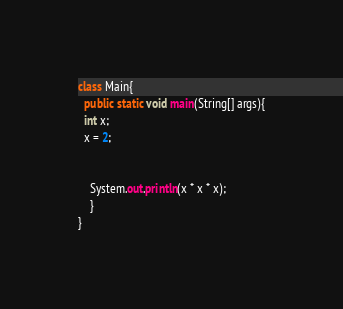Convert code to text. <code><loc_0><loc_0><loc_500><loc_500><_Java_>class Main{
  public static void main(String[] args){
  int x;
  x = 2;
 
 
    System.out.println(x * x * x);
    }
}</code> 